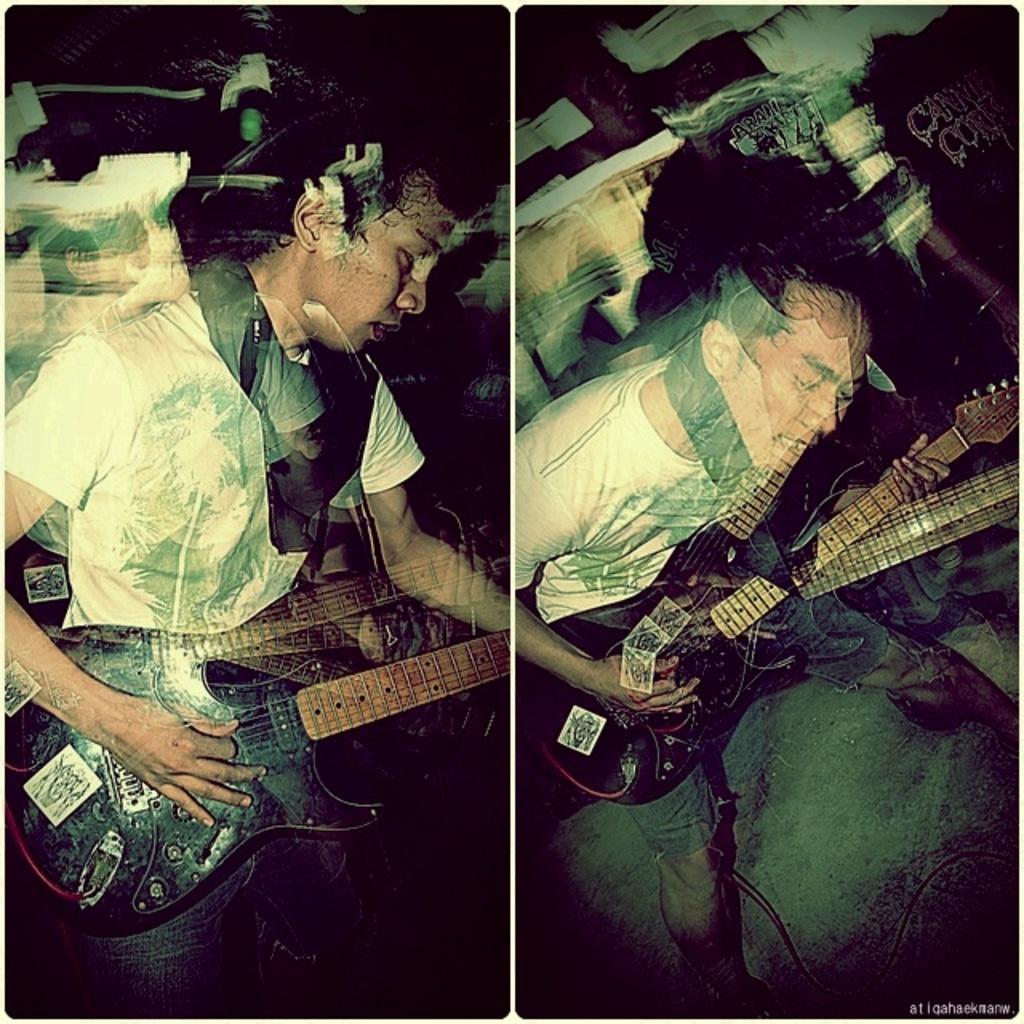Describe this image in one or two sentences. It is a collage image, it is edited, both the people who are shown in the image are holding the guitar, both the persons are same. 